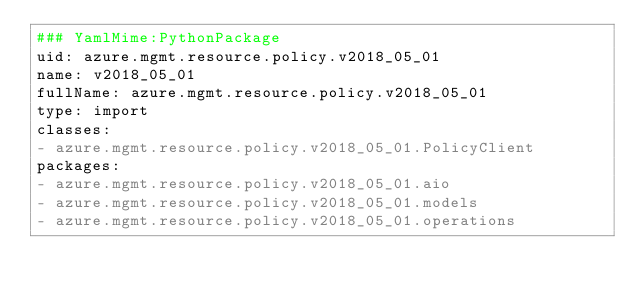Convert code to text. <code><loc_0><loc_0><loc_500><loc_500><_YAML_>### YamlMime:PythonPackage
uid: azure.mgmt.resource.policy.v2018_05_01
name: v2018_05_01
fullName: azure.mgmt.resource.policy.v2018_05_01
type: import
classes:
- azure.mgmt.resource.policy.v2018_05_01.PolicyClient
packages:
- azure.mgmt.resource.policy.v2018_05_01.aio
- azure.mgmt.resource.policy.v2018_05_01.models
- azure.mgmt.resource.policy.v2018_05_01.operations
</code> 